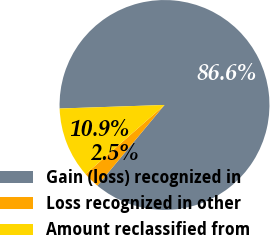<chart> <loc_0><loc_0><loc_500><loc_500><pie_chart><fcel>Gain (loss) recognized in<fcel>Loss recognized in other<fcel>Amount reclassified from<nl><fcel>86.58%<fcel>2.51%<fcel>10.91%<nl></chart> 